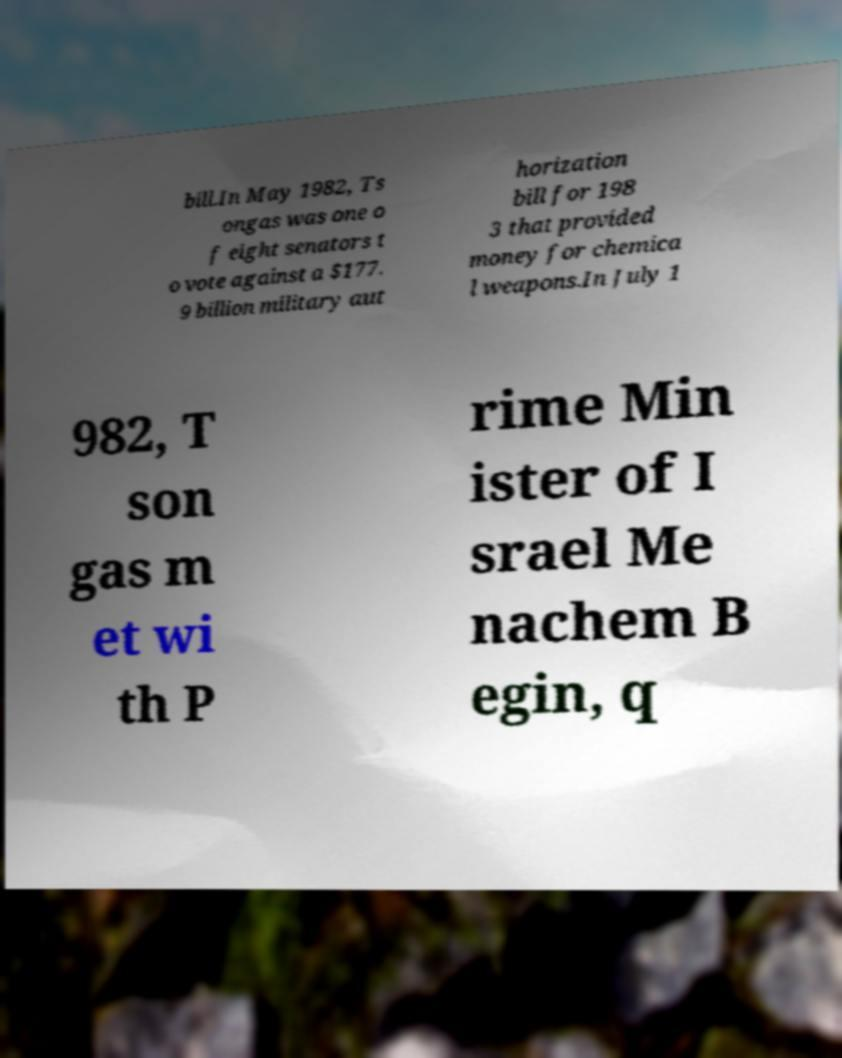For documentation purposes, I need the text within this image transcribed. Could you provide that? bill.In May 1982, Ts ongas was one o f eight senators t o vote against a $177. 9 billion military aut horization bill for 198 3 that provided money for chemica l weapons.In July 1 982, T son gas m et wi th P rime Min ister of I srael Me nachem B egin, q 